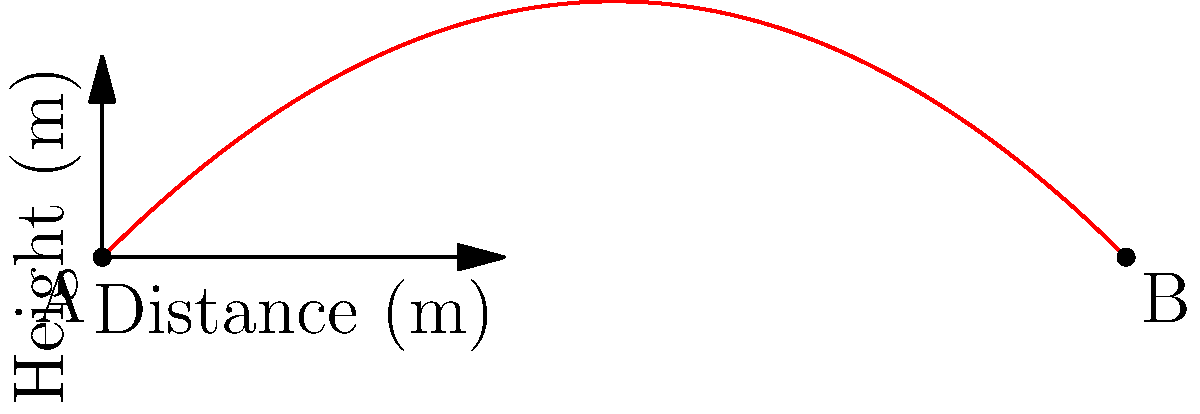A trebuchet, an ancient war machine, launches a cannonball with an initial velocity of 50 m/s at a 45-degree angle from the horizontal. Neglecting air resistance, what is the maximum height reached by the cannonball during its trajectory? To find the maximum height of the cannonball's trajectory, we'll follow these steps:

1) The initial velocity components are:
   $v_{0x} = v_0 \cos(\theta) = 50 \cos(45°) = 35.36$ m/s
   $v_{0y} = v_0 \sin(\theta) = 50 \sin(45°) = 35.36$ m/s

2) The time to reach maximum height is when the vertical velocity becomes zero:
   $v_y = v_{0y} - gt = 0$
   $t = \frac{v_{0y}}{g} = \frac{35.36}{9.8} = 3.61$ s

3) The maximum height can be calculated using the equation:
   $h = v_{0y}t - \frac{1}{2}gt^2$

4) Substituting the values:
   $h = (35.36)(3.61) - \frac{1}{2}(9.8)(3.61)^2$
   $h = 127.65 - 63.82 = 63.83$ m

Therefore, the maximum height reached by the cannonball is approximately 63.83 meters.
Answer: 63.83 m 